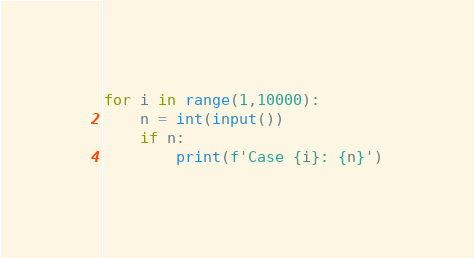<code> <loc_0><loc_0><loc_500><loc_500><_Python_>for i in range(1,10000):
    n = int(input())
    if n:
        print(f'Case {i}: {n}')
</code> 